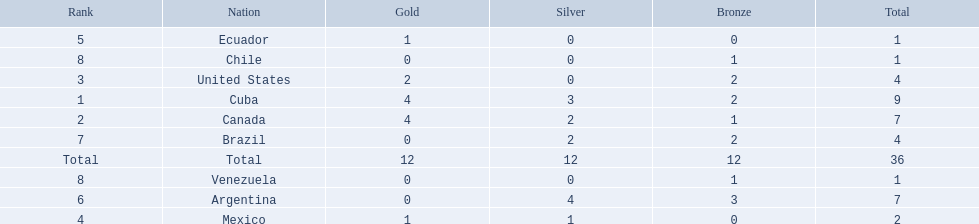What countries participated? Cuba, 4, 3, 2, Canada, 4, 2, 1, United States, 2, 0, 2, Mexico, 1, 1, 0, Ecuador, 1, 0, 0, Argentina, 0, 4, 3, Brazil, 0, 2, 2, Chile, 0, 0, 1, Venezuela, 0, 0, 1. What countries won 1 gold Mexico, 1, 1, 0, Ecuador, 1, 0, 0. What country above also won no silver? Ecuador. 